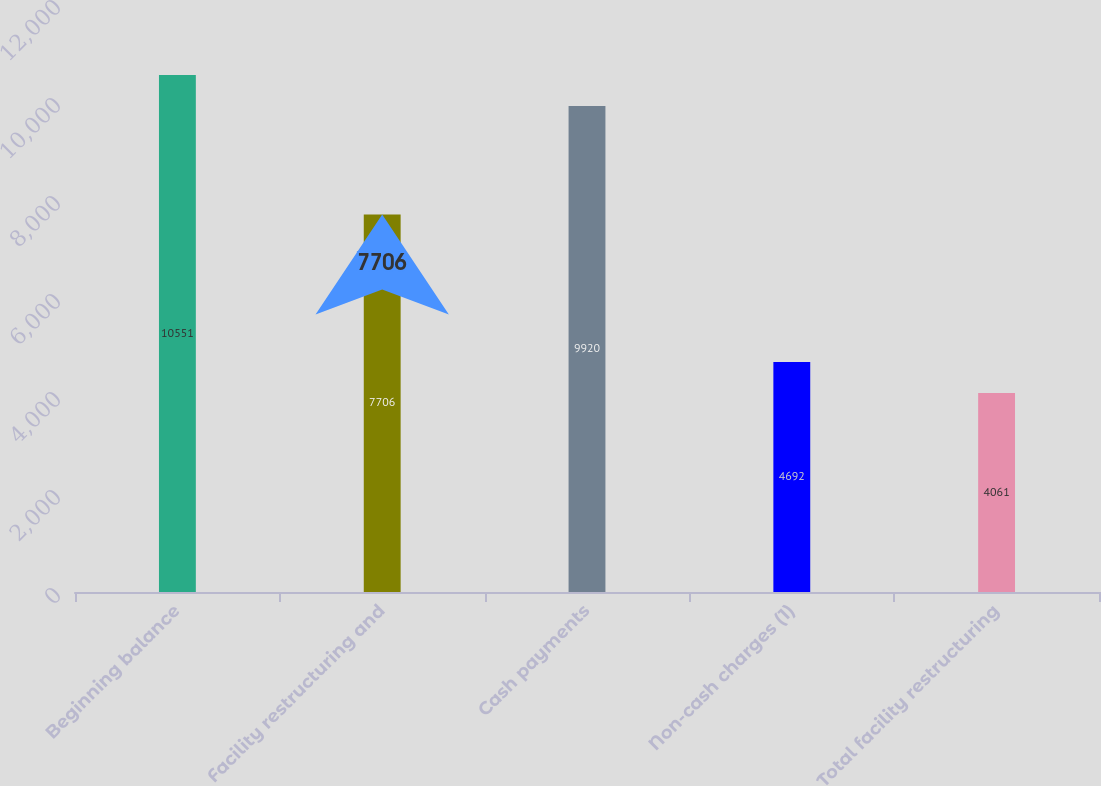Convert chart. <chart><loc_0><loc_0><loc_500><loc_500><bar_chart><fcel>Beginning balance<fcel>Facility restructuring and<fcel>Cash payments<fcel>Non-cash charges (1)<fcel>Total facility restructuring<nl><fcel>10551<fcel>7706<fcel>9920<fcel>4692<fcel>4061<nl></chart> 